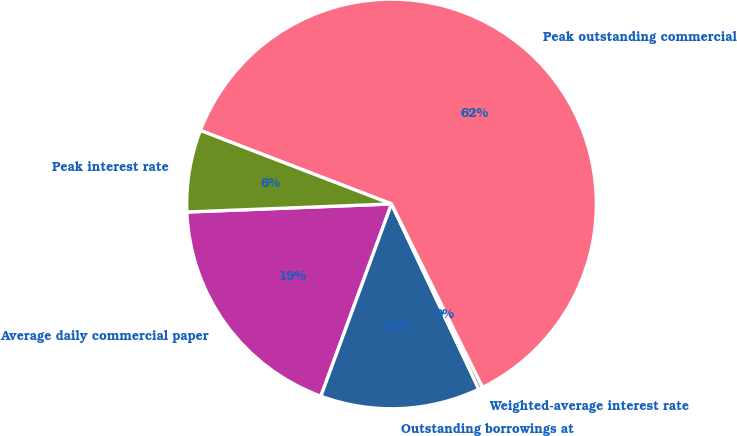Convert chart to OTSL. <chart><loc_0><loc_0><loc_500><loc_500><pie_chart><fcel>Average daily commercial paper<fcel>Outstanding borrowings at<fcel>Weighted-average interest rate<fcel>Peak outstanding commercial<fcel>Peak interest rate<nl><fcel>18.77%<fcel>12.62%<fcel>0.32%<fcel>61.83%<fcel>6.47%<nl></chart> 